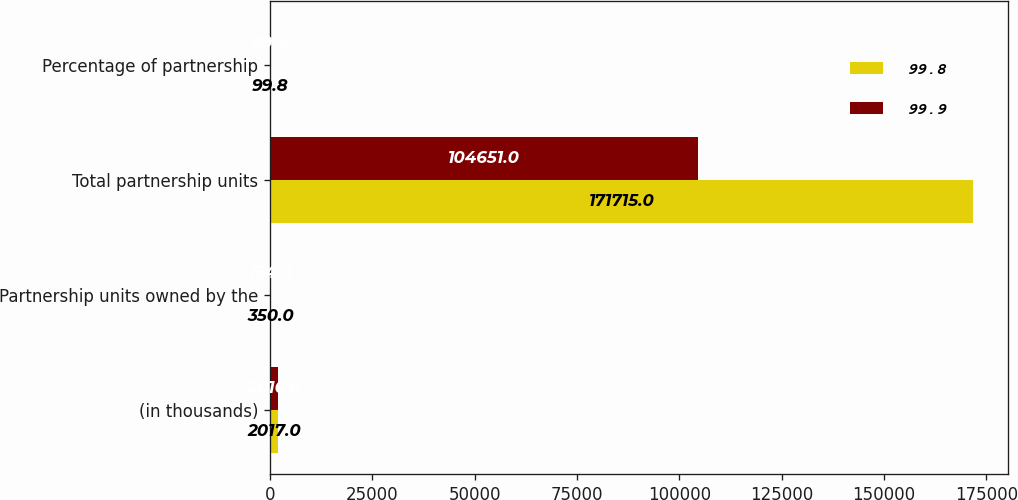<chart> <loc_0><loc_0><loc_500><loc_500><stacked_bar_chart><ecel><fcel>(in thousands)<fcel>Partnership units owned by the<fcel>Total partnership units<fcel>Percentage of partnership<nl><fcel>99.8<fcel>2017<fcel>350<fcel>171715<fcel>99.8<nl><fcel>99.9<fcel>2016<fcel>154<fcel>104651<fcel>99.9<nl></chart> 